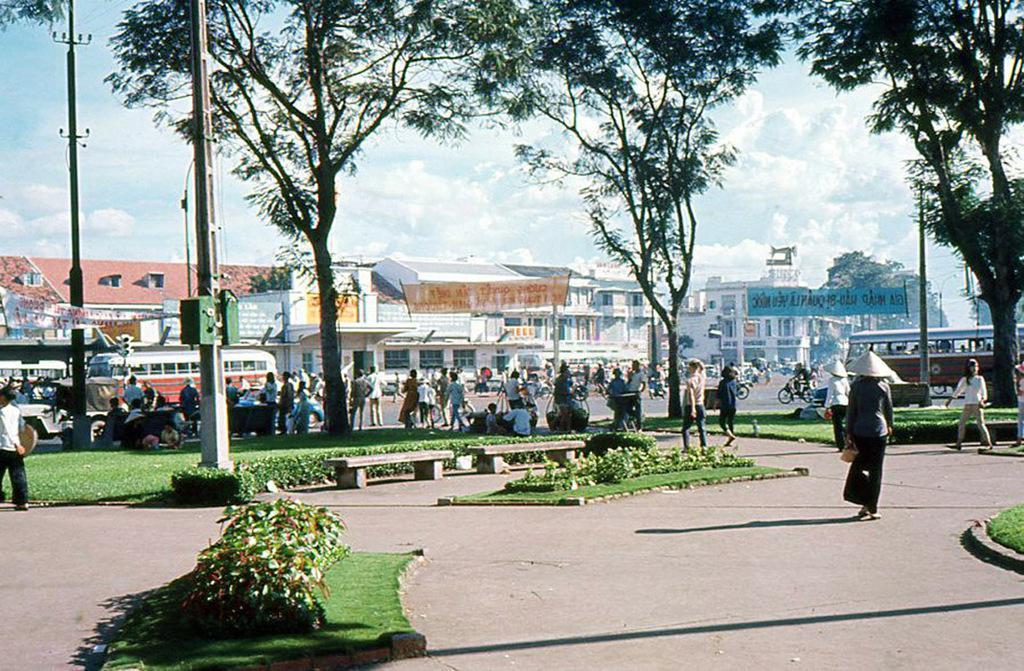Can you describe this image briefly? In the picture,there are many people and around the people they are some trees and grass and in the background there are many buildings and some vehicles are moving in front of the buildings. 